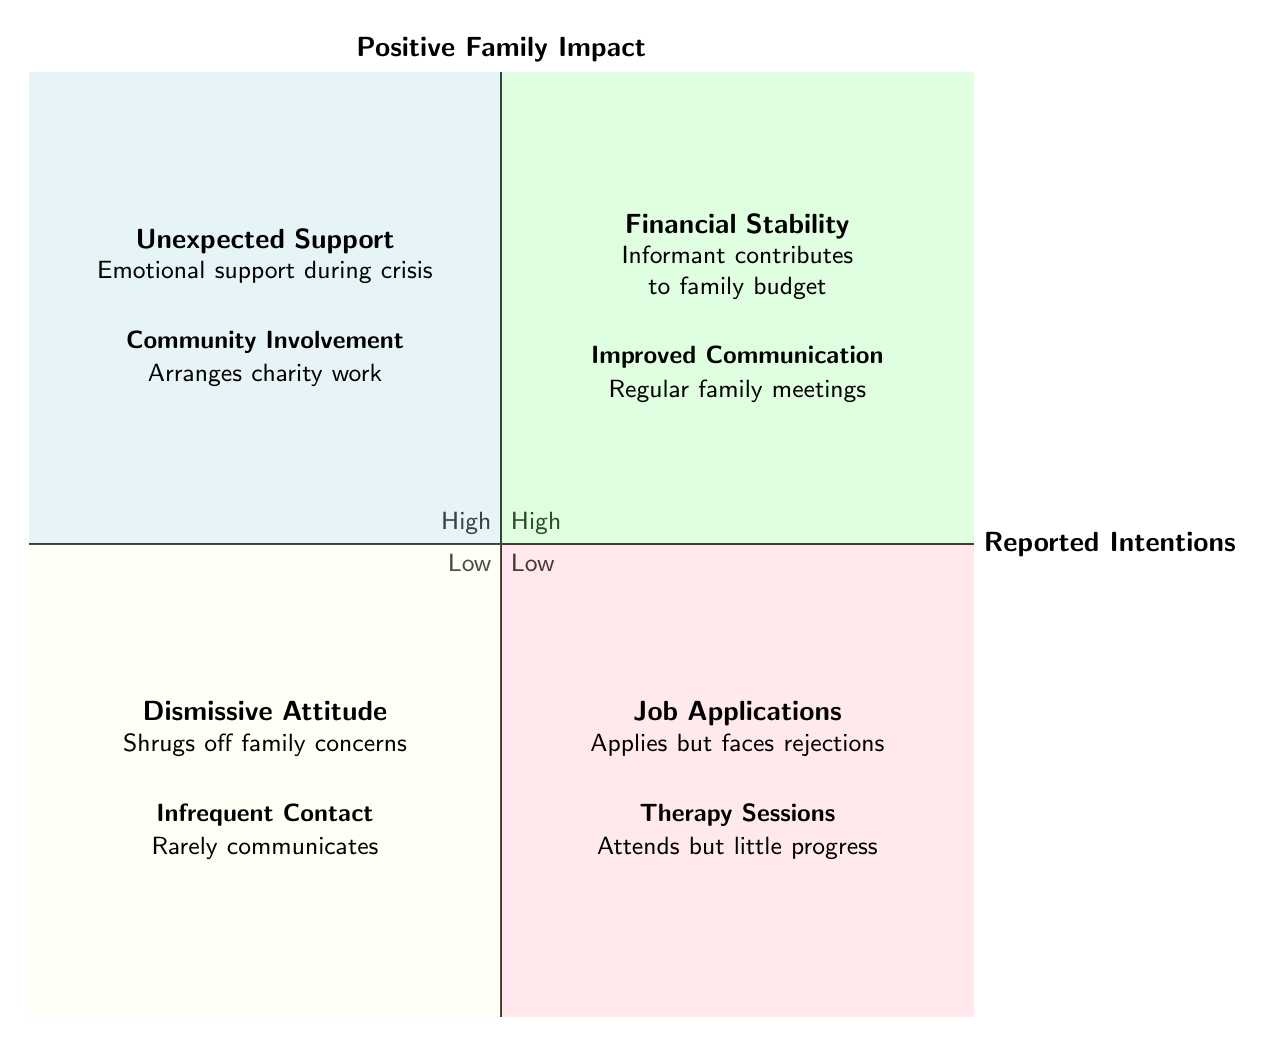What are the titles in the high positive impact and high intentions quadrant? In the high positive impact and high intentions quadrant (top right), the titles are "Financial Stability" and "Improved Communication".
Answer: Financial Stability, Improved Communication How many titles are there in the low positive impact and low intentions quadrant? The low positive impact and low intentions quadrant (bottom left) contains two titles: "Dismissive Attitude" and "Infrequent Contact". Therefore, there are two titles in this quadrant.
Answer: 2 What is the description for "Unexpected Support"? The description for "Unexpected Support" in the high positive impact and low intentions quadrant states that the informant provides emotional support during a crisis without being asked.
Answer: Emotional support during a crisis without being asked Which quadrant contains "Therapy Sessions"? "Therapy Sessions" is located in the low positive impact and high intentions quadrant (bottom right). This quadrant represents situations where intentions are high, but the impact is low.
Answer: Low positive impact, high intentions quadrant Which quadrant has the highest positivity impact? The quadrant with the highest positive family impact is the high positive impact and high intentions quadrant (top right). It indicates strong positive effects combined with strong intentions.
Answer: High positive impact and high intentions quadrant What is the relationship between "Job Applications" and positive family impact? "Job Applications" is positioned in the low positive impact and high intentions quadrant, indicating that even though the informant has high intentions in applying for jobs, it results in low positive family impact.
Answer: Low positive impact Which quadrant has the least positive family impact? The quadrant with the least positive family impact is the low positive impact and low intentions quadrant (bottom left), as both indicators are low.
Answer: Low positive impact and low intentions quadrant What are the descriptions in the high positive impact and low intentions quadrant? The high positive impact and low intentions quadrant contains two descriptions: "Unexpected Support," which states the informant provides emotional support during a crisis without being asked, and "Community Involvement," which mentions the informant arranges charity work benefiting the family.
Answer: Unexpected Support, Community Involvement What is the meaning of "Dismissive Attitude"? The meaning of "Dismissive Attitude" in the low positive impact and low intentions quadrant conveys that the informant often shrugs off family concerns, indicating a lack of engagement or care for family issues.
Answer: Shrugs off family concerns 